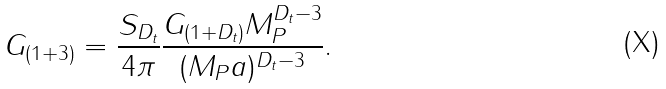Convert formula to latex. <formula><loc_0><loc_0><loc_500><loc_500>G _ { ( 1 + 3 ) } = \frac { S _ { D _ { t } } } { 4 \pi } \frac { G _ { ( 1 + D _ { t } ) } M _ { P } ^ { D _ { t } - 3 } } { ( M _ { P } a ) ^ { D _ { t } - 3 } } .</formula> 